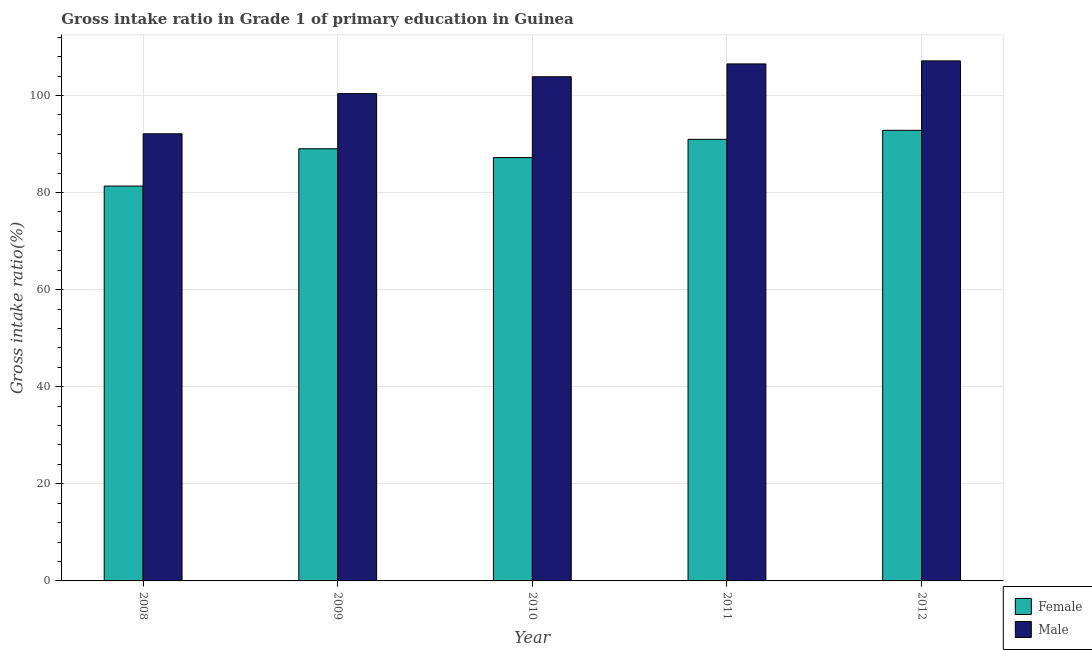How many different coloured bars are there?
Offer a terse response. 2. Are the number of bars per tick equal to the number of legend labels?
Your answer should be compact. Yes. Are the number of bars on each tick of the X-axis equal?
Keep it short and to the point. Yes. How many bars are there on the 4th tick from the left?
Ensure brevity in your answer.  2. In how many cases, is the number of bars for a given year not equal to the number of legend labels?
Offer a terse response. 0. What is the gross intake ratio(male) in 2011?
Your answer should be very brief. 106.49. Across all years, what is the maximum gross intake ratio(male)?
Offer a terse response. 107.12. Across all years, what is the minimum gross intake ratio(male)?
Your answer should be compact. 92.1. In which year was the gross intake ratio(female) minimum?
Provide a succinct answer. 2008. What is the total gross intake ratio(male) in the graph?
Provide a succinct answer. 509.92. What is the difference between the gross intake ratio(female) in 2008 and that in 2009?
Your response must be concise. -7.68. What is the difference between the gross intake ratio(female) in 2008 and the gross intake ratio(male) in 2012?
Ensure brevity in your answer.  -11.48. What is the average gross intake ratio(female) per year?
Give a very brief answer. 88.26. In the year 2012, what is the difference between the gross intake ratio(female) and gross intake ratio(male)?
Keep it short and to the point. 0. In how many years, is the gross intake ratio(female) greater than 8 %?
Make the answer very short. 5. What is the ratio of the gross intake ratio(male) in 2009 to that in 2010?
Give a very brief answer. 0.97. Is the gross intake ratio(male) in 2011 less than that in 2012?
Make the answer very short. Yes. Is the difference between the gross intake ratio(female) in 2009 and 2010 greater than the difference between the gross intake ratio(male) in 2009 and 2010?
Offer a terse response. No. What is the difference between the highest and the second highest gross intake ratio(female)?
Provide a short and direct response. 1.85. What is the difference between the highest and the lowest gross intake ratio(female)?
Offer a terse response. 11.48. In how many years, is the gross intake ratio(male) greater than the average gross intake ratio(male) taken over all years?
Your response must be concise. 3. What does the 2nd bar from the right in 2011 represents?
Offer a terse response. Female. How many years are there in the graph?
Give a very brief answer. 5. Are the values on the major ticks of Y-axis written in scientific E-notation?
Keep it short and to the point. No. Does the graph contain any zero values?
Your response must be concise. No. Does the graph contain grids?
Provide a short and direct response. Yes. How many legend labels are there?
Your answer should be very brief. 2. What is the title of the graph?
Offer a terse response. Gross intake ratio in Grade 1 of primary education in Guinea. Does "Females" appear as one of the legend labels in the graph?
Provide a short and direct response. No. What is the label or title of the Y-axis?
Your answer should be very brief. Gross intake ratio(%). What is the Gross intake ratio(%) in Female in 2008?
Your response must be concise. 81.33. What is the Gross intake ratio(%) of Male in 2008?
Make the answer very short. 92.1. What is the Gross intake ratio(%) of Female in 2009?
Ensure brevity in your answer.  89.01. What is the Gross intake ratio(%) in Male in 2009?
Offer a very short reply. 100.37. What is the Gross intake ratio(%) in Female in 2010?
Offer a very short reply. 87.2. What is the Gross intake ratio(%) of Male in 2010?
Your answer should be very brief. 103.85. What is the Gross intake ratio(%) of Female in 2011?
Make the answer very short. 90.96. What is the Gross intake ratio(%) of Male in 2011?
Your response must be concise. 106.49. What is the Gross intake ratio(%) in Female in 2012?
Your answer should be compact. 92.81. What is the Gross intake ratio(%) in Male in 2012?
Your answer should be very brief. 107.12. Across all years, what is the maximum Gross intake ratio(%) of Female?
Offer a very short reply. 92.81. Across all years, what is the maximum Gross intake ratio(%) in Male?
Ensure brevity in your answer.  107.12. Across all years, what is the minimum Gross intake ratio(%) in Female?
Ensure brevity in your answer.  81.33. Across all years, what is the minimum Gross intake ratio(%) of Male?
Your response must be concise. 92.1. What is the total Gross intake ratio(%) of Female in the graph?
Your answer should be compact. 441.31. What is the total Gross intake ratio(%) of Male in the graph?
Provide a short and direct response. 509.92. What is the difference between the Gross intake ratio(%) in Female in 2008 and that in 2009?
Your answer should be very brief. -7.68. What is the difference between the Gross intake ratio(%) in Male in 2008 and that in 2009?
Provide a succinct answer. -8.27. What is the difference between the Gross intake ratio(%) of Female in 2008 and that in 2010?
Ensure brevity in your answer.  -5.87. What is the difference between the Gross intake ratio(%) of Male in 2008 and that in 2010?
Ensure brevity in your answer.  -11.75. What is the difference between the Gross intake ratio(%) of Female in 2008 and that in 2011?
Ensure brevity in your answer.  -9.63. What is the difference between the Gross intake ratio(%) of Male in 2008 and that in 2011?
Your answer should be compact. -14.39. What is the difference between the Gross intake ratio(%) in Female in 2008 and that in 2012?
Offer a terse response. -11.48. What is the difference between the Gross intake ratio(%) in Male in 2008 and that in 2012?
Your response must be concise. -15.02. What is the difference between the Gross intake ratio(%) of Female in 2009 and that in 2010?
Offer a terse response. 1.81. What is the difference between the Gross intake ratio(%) of Male in 2009 and that in 2010?
Your response must be concise. -3.48. What is the difference between the Gross intake ratio(%) of Female in 2009 and that in 2011?
Provide a short and direct response. -1.94. What is the difference between the Gross intake ratio(%) of Male in 2009 and that in 2011?
Keep it short and to the point. -6.12. What is the difference between the Gross intake ratio(%) in Female in 2009 and that in 2012?
Offer a terse response. -3.8. What is the difference between the Gross intake ratio(%) in Male in 2009 and that in 2012?
Offer a terse response. -6.74. What is the difference between the Gross intake ratio(%) in Female in 2010 and that in 2011?
Your response must be concise. -3.75. What is the difference between the Gross intake ratio(%) of Male in 2010 and that in 2011?
Keep it short and to the point. -2.64. What is the difference between the Gross intake ratio(%) in Female in 2010 and that in 2012?
Ensure brevity in your answer.  -5.61. What is the difference between the Gross intake ratio(%) in Male in 2010 and that in 2012?
Offer a terse response. -3.27. What is the difference between the Gross intake ratio(%) in Female in 2011 and that in 2012?
Your response must be concise. -1.85. What is the difference between the Gross intake ratio(%) in Male in 2011 and that in 2012?
Make the answer very short. -0.63. What is the difference between the Gross intake ratio(%) in Female in 2008 and the Gross intake ratio(%) in Male in 2009?
Keep it short and to the point. -19.04. What is the difference between the Gross intake ratio(%) of Female in 2008 and the Gross intake ratio(%) of Male in 2010?
Make the answer very short. -22.52. What is the difference between the Gross intake ratio(%) of Female in 2008 and the Gross intake ratio(%) of Male in 2011?
Ensure brevity in your answer.  -25.16. What is the difference between the Gross intake ratio(%) in Female in 2008 and the Gross intake ratio(%) in Male in 2012?
Keep it short and to the point. -25.79. What is the difference between the Gross intake ratio(%) in Female in 2009 and the Gross intake ratio(%) in Male in 2010?
Provide a succinct answer. -14.84. What is the difference between the Gross intake ratio(%) in Female in 2009 and the Gross intake ratio(%) in Male in 2011?
Ensure brevity in your answer.  -17.48. What is the difference between the Gross intake ratio(%) in Female in 2009 and the Gross intake ratio(%) in Male in 2012?
Provide a short and direct response. -18.1. What is the difference between the Gross intake ratio(%) of Female in 2010 and the Gross intake ratio(%) of Male in 2011?
Give a very brief answer. -19.29. What is the difference between the Gross intake ratio(%) of Female in 2010 and the Gross intake ratio(%) of Male in 2012?
Offer a terse response. -19.91. What is the difference between the Gross intake ratio(%) of Female in 2011 and the Gross intake ratio(%) of Male in 2012?
Provide a succinct answer. -16.16. What is the average Gross intake ratio(%) in Female per year?
Provide a succinct answer. 88.26. What is the average Gross intake ratio(%) in Male per year?
Ensure brevity in your answer.  101.98. In the year 2008, what is the difference between the Gross intake ratio(%) in Female and Gross intake ratio(%) in Male?
Offer a terse response. -10.77. In the year 2009, what is the difference between the Gross intake ratio(%) of Female and Gross intake ratio(%) of Male?
Ensure brevity in your answer.  -11.36. In the year 2010, what is the difference between the Gross intake ratio(%) in Female and Gross intake ratio(%) in Male?
Keep it short and to the point. -16.65. In the year 2011, what is the difference between the Gross intake ratio(%) of Female and Gross intake ratio(%) of Male?
Provide a succinct answer. -15.53. In the year 2012, what is the difference between the Gross intake ratio(%) of Female and Gross intake ratio(%) of Male?
Keep it short and to the point. -14.3. What is the ratio of the Gross intake ratio(%) in Female in 2008 to that in 2009?
Provide a short and direct response. 0.91. What is the ratio of the Gross intake ratio(%) of Male in 2008 to that in 2009?
Offer a very short reply. 0.92. What is the ratio of the Gross intake ratio(%) of Female in 2008 to that in 2010?
Provide a short and direct response. 0.93. What is the ratio of the Gross intake ratio(%) of Male in 2008 to that in 2010?
Give a very brief answer. 0.89. What is the ratio of the Gross intake ratio(%) of Female in 2008 to that in 2011?
Ensure brevity in your answer.  0.89. What is the ratio of the Gross intake ratio(%) of Male in 2008 to that in 2011?
Offer a terse response. 0.86. What is the ratio of the Gross intake ratio(%) in Female in 2008 to that in 2012?
Ensure brevity in your answer.  0.88. What is the ratio of the Gross intake ratio(%) in Male in 2008 to that in 2012?
Ensure brevity in your answer.  0.86. What is the ratio of the Gross intake ratio(%) in Female in 2009 to that in 2010?
Your answer should be very brief. 1.02. What is the ratio of the Gross intake ratio(%) of Male in 2009 to that in 2010?
Your answer should be very brief. 0.97. What is the ratio of the Gross intake ratio(%) of Female in 2009 to that in 2011?
Make the answer very short. 0.98. What is the ratio of the Gross intake ratio(%) in Male in 2009 to that in 2011?
Offer a terse response. 0.94. What is the ratio of the Gross intake ratio(%) of Female in 2009 to that in 2012?
Your answer should be compact. 0.96. What is the ratio of the Gross intake ratio(%) of Male in 2009 to that in 2012?
Offer a terse response. 0.94. What is the ratio of the Gross intake ratio(%) of Female in 2010 to that in 2011?
Your answer should be very brief. 0.96. What is the ratio of the Gross intake ratio(%) in Male in 2010 to that in 2011?
Your answer should be compact. 0.98. What is the ratio of the Gross intake ratio(%) of Female in 2010 to that in 2012?
Provide a short and direct response. 0.94. What is the ratio of the Gross intake ratio(%) of Male in 2010 to that in 2012?
Your response must be concise. 0.97. What is the ratio of the Gross intake ratio(%) of Female in 2011 to that in 2012?
Give a very brief answer. 0.98. What is the difference between the highest and the second highest Gross intake ratio(%) of Female?
Your response must be concise. 1.85. What is the difference between the highest and the second highest Gross intake ratio(%) in Male?
Your answer should be very brief. 0.63. What is the difference between the highest and the lowest Gross intake ratio(%) in Female?
Your answer should be compact. 11.48. What is the difference between the highest and the lowest Gross intake ratio(%) in Male?
Ensure brevity in your answer.  15.02. 